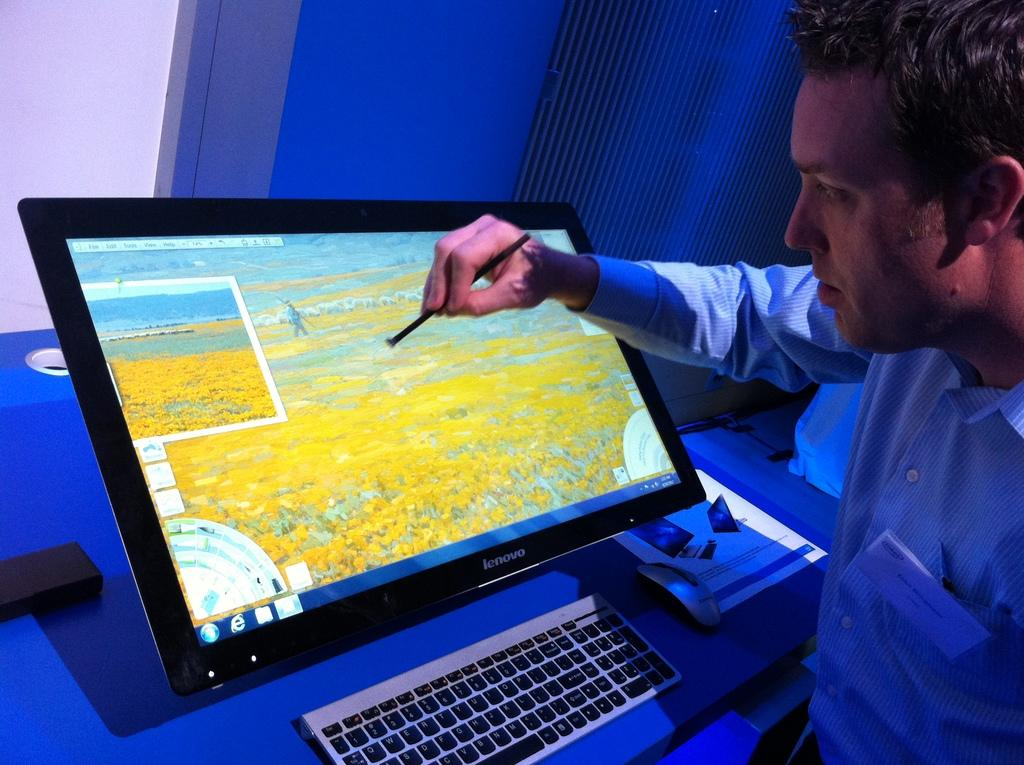<image>
Write a terse but informative summary of the picture. A man draws with a stylus on his Lenovo monitor. 